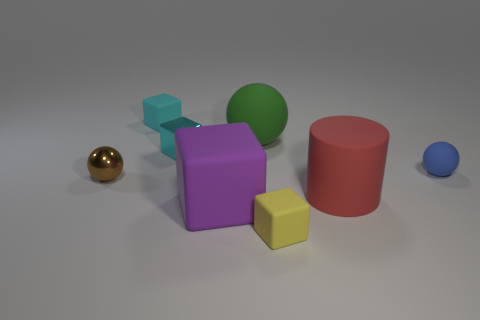Are there any small cyan blocks that have the same material as the brown thing?
Provide a short and direct response. Yes. Does the large green object have the same material as the tiny brown thing?
Ensure brevity in your answer.  No. There is another metal block that is the same size as the yellow block; what is its color?
Make the answer very short. Cyan. What number of other things are the same shape as the small blue matte thing?
Ensure brevity in your answer.  2. There is a green thing; is it the same size as the shiny thing that is in front of the tiny blue rubber thing?
Keep it short and to the point. No. How many things are either purple rubber things or large red metal cylinders?
Make the answer very short. 1. What number of other objects are there of the same size as the green rubber thing?
Offer a very short reply. 2. Do the cylinder and the tiny rubber object that is in front of the purple object have the same color?
Offer a terse response. No. What number of cubes are tiny matte objects or purple objects?
Offer a very short reply. 3. Is there any other thing that is the same color as the matte cylinder?
Provide a succinct answer. No. 